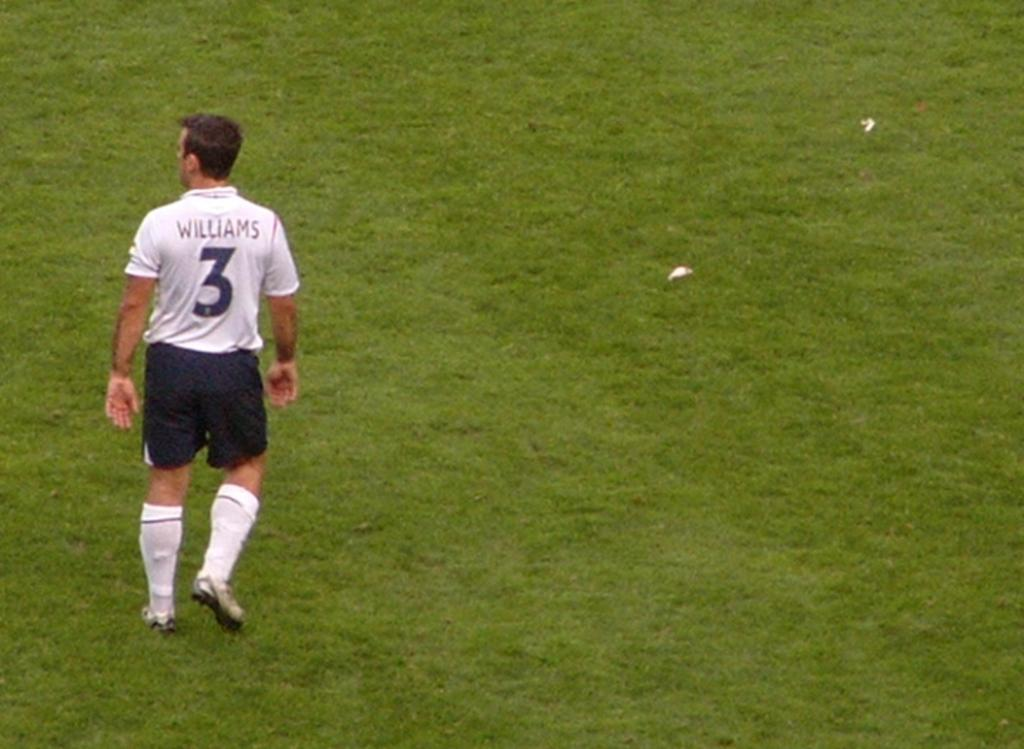Provide a one-sentence caption for the provided image. a sports player with the name WILLIAMS and # on the back of his shirt standing on some grass. 